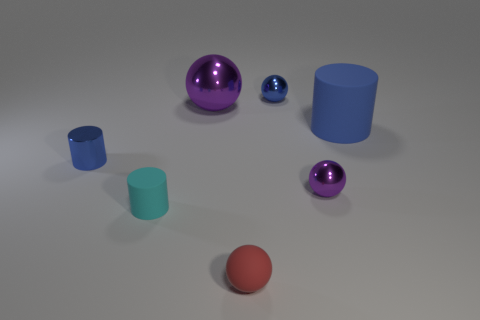What is the material of the big thing that is the same color as the small metallic cylinder?
Your answer should be very brief. Rubber. What is the size of the blue object that is in front of the blue cylinder that is to the right of the cyan rubber thing?
Offer a terse response. Small. Do the large rubber thing and the object on the left side of the small matte cylinder have the same color?
Your response must be concise. Yes. Is there a blue metal ball that has the same size as the cyan cylinder?
Ensure brevity in your answer.  Yes. There is a purple ball that is left of the tiny rubber sphere; what size is it?
Provide a succinct answer. Large. There is a tiny purple sphere left of the big rubber cylinder; are there any big blue objects that are behind it?
Your answer should be compact. Yes. What number of other things are there of the same shape as the large blue thing?
Provide a succinct answer. 2. Do the large purple metallic thing and the red thing have the same shape?
Offer a terse response. Yes. There is a matte thing that is both behind the small rubber sphere and on the left side of the big blue rubber object; what is its color?
Your answer should be compact. Cyan. The other object that is the same color as the big metallic thing is what size?
Your answer should be very brief. Small. 